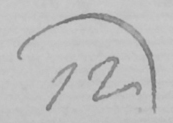Can you read and transcribe this handwriting? 12 ) 